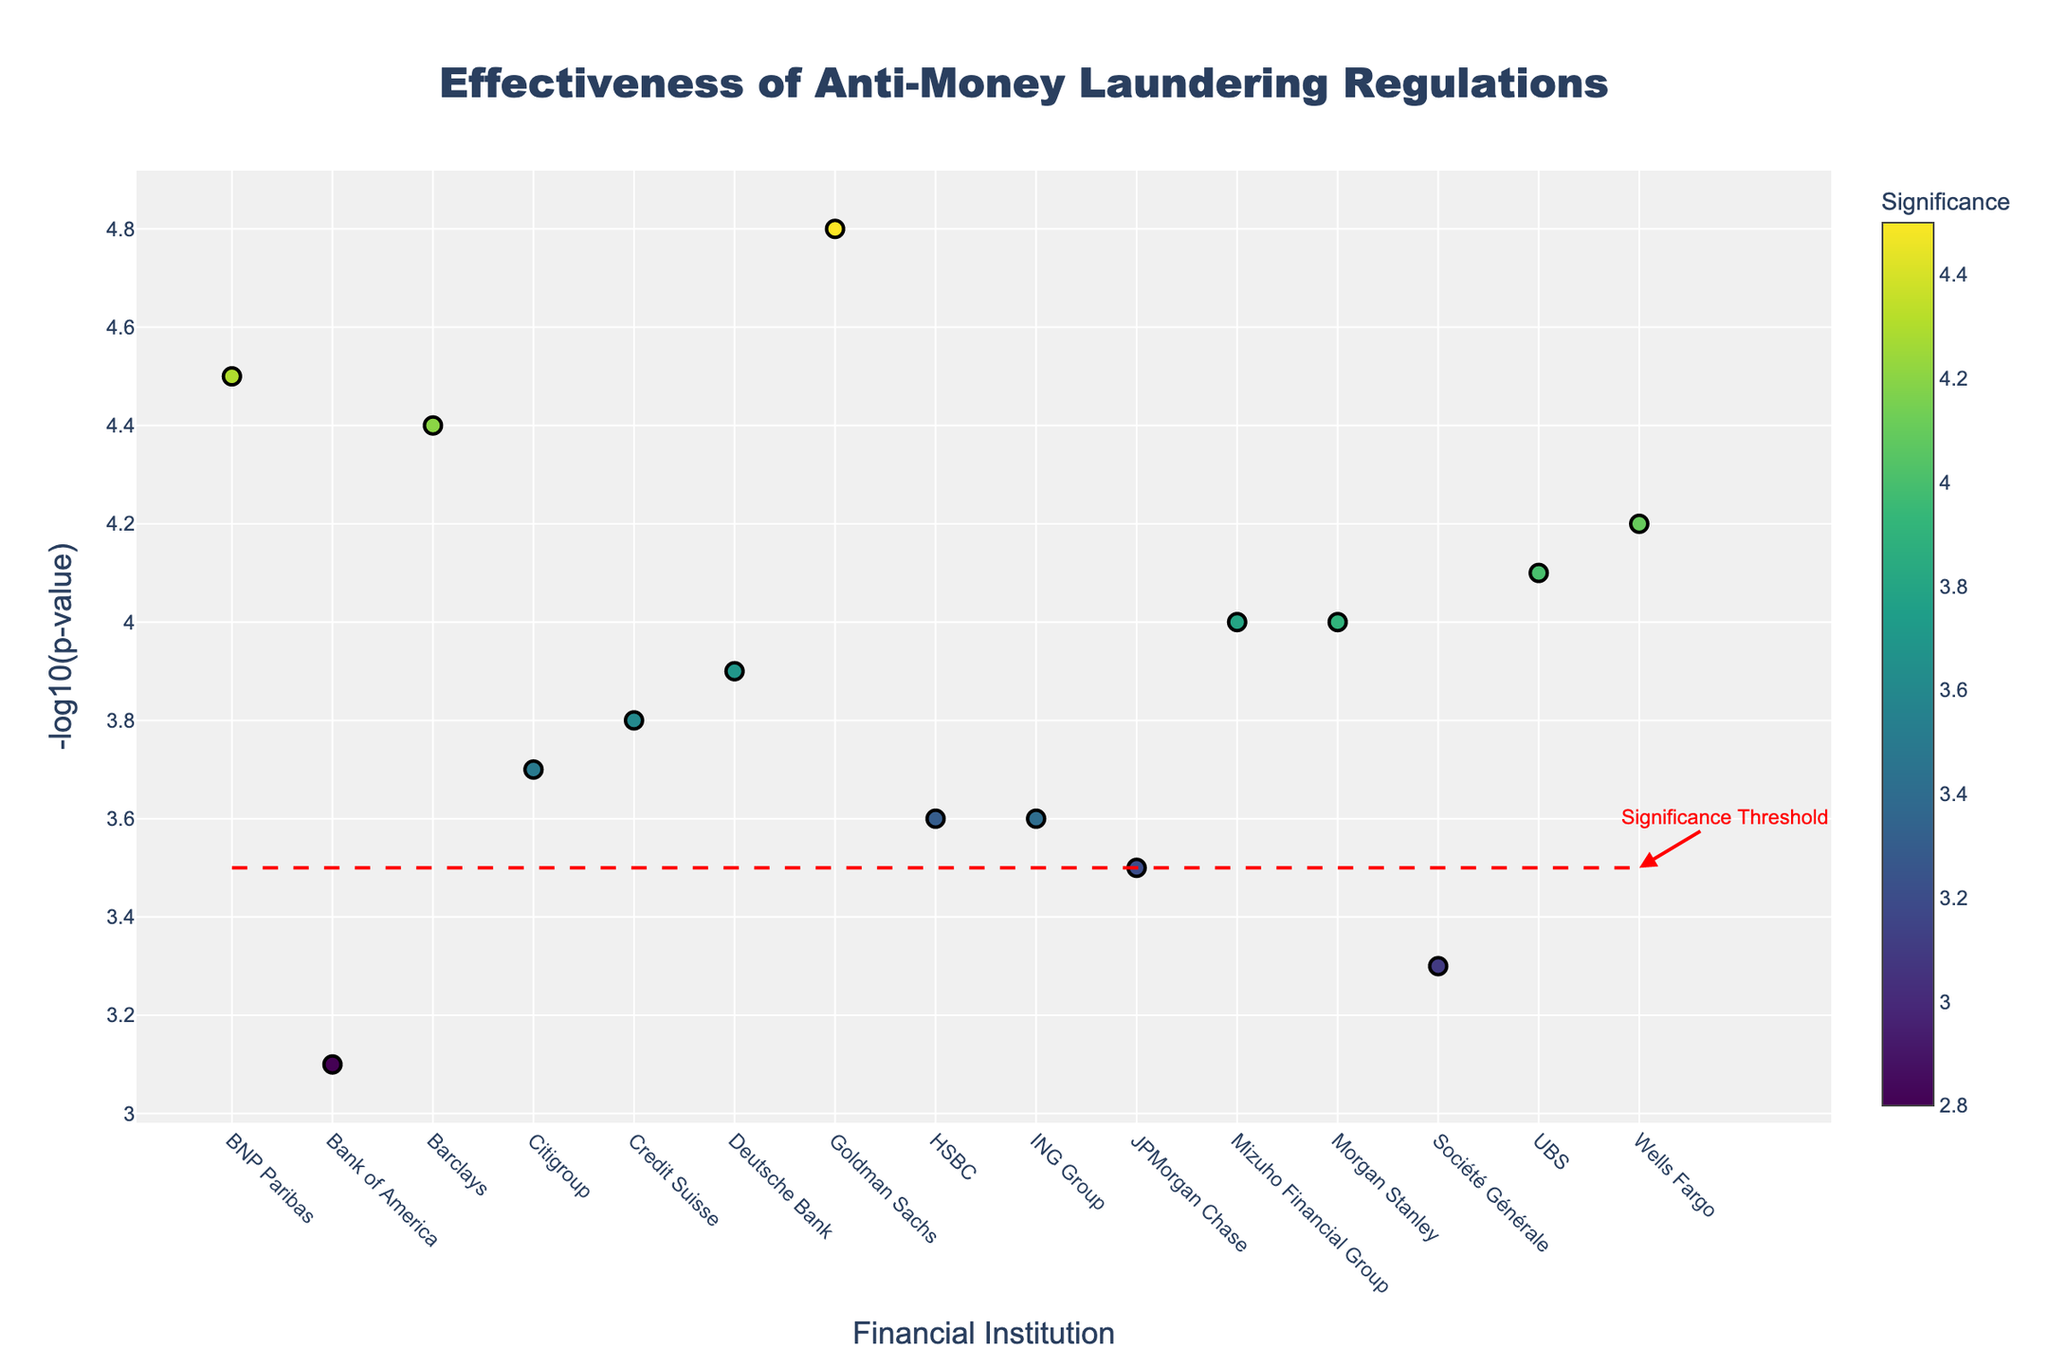Which financial institution has the highest -log10(p-value) in the figure? Look for the highest point on the y-axis and check its corresponding x-axis label. The highest -log10(p-value) is at 4.8, which corresponds to Goldman Sachs.
Answer: Goldman Sachs What is the overall trend for the financial institutions’ significance in the Manhattan plot? Observe the color gradient of the markers, which represents significance. Darker colors indicate higher significance. Based on the colors, the significance varies across institutions with a notable cluster of higher significance around a few institutions like Goldman Sachs and BNP Paribas.
Answer: Varies, with a high cluster around some institutions How many financial institutions have a -log10(p-value) greater than the significance threshold of 3.5? Count the points above the red dashed line marked at 3.5 on the y-axis. There are 13 points above this threshold.
Answer: 13 Which regulation shows the highest significance according to the plot? Identify the marker with the darkest color and most significant p-value. Hovering over the highest point (4.8) reveals "FATF Recommendations" as the regulation.
Answer: FATF Recommendations Which financial institution is represented by the 6th data point, and what is its -log10(p-value)? Count the financial institutions from left to right. The 6th point corresponds to Deutsche Bank. By checking the y-axis value, its -log10(p-value) is 3.9.
Answer: Deutsche Bank, 3.9 Compare the -log10(p-value) for CDD at JPMorgan Chase and PEP Screening at HSBC. Which is higher? Look at the y-values for the specified regulations. CDD at JPMorgan Chase has a value of 3.5, while PEP Screening at HSBC has a value of 3.6. Thus, HSBC’s value is higher.
Answer: HSBC’s PEP Screening What is the smallest -log10(p-value) shown in the plot, and which financial institution does it correspond to? Find the lowest point on the y-axis, which is at 3.1, and check the corresponding x-axis label. It corresponds to Bank of America.
Answer: 3.1, Bank of America Identify the primary color scale used in the plot and explain its relevance to the data. The color scale used is "Viridis," which is a gradient ranging from yellow to dark purple, representing varying levels of significance. Higher significance is denoted by darker colors.
Answer: Viridis scale; represents significance Which regulation is associated with the second-highest -log10(p-value), and what is that value? Identify the second-highest point on the y-axis, which is at 4.5, and check the associated regulation by hovering over it. It is “Suspicious Activity Reporting”.
Answer: Suspicious Activity Reporting, 4.5 